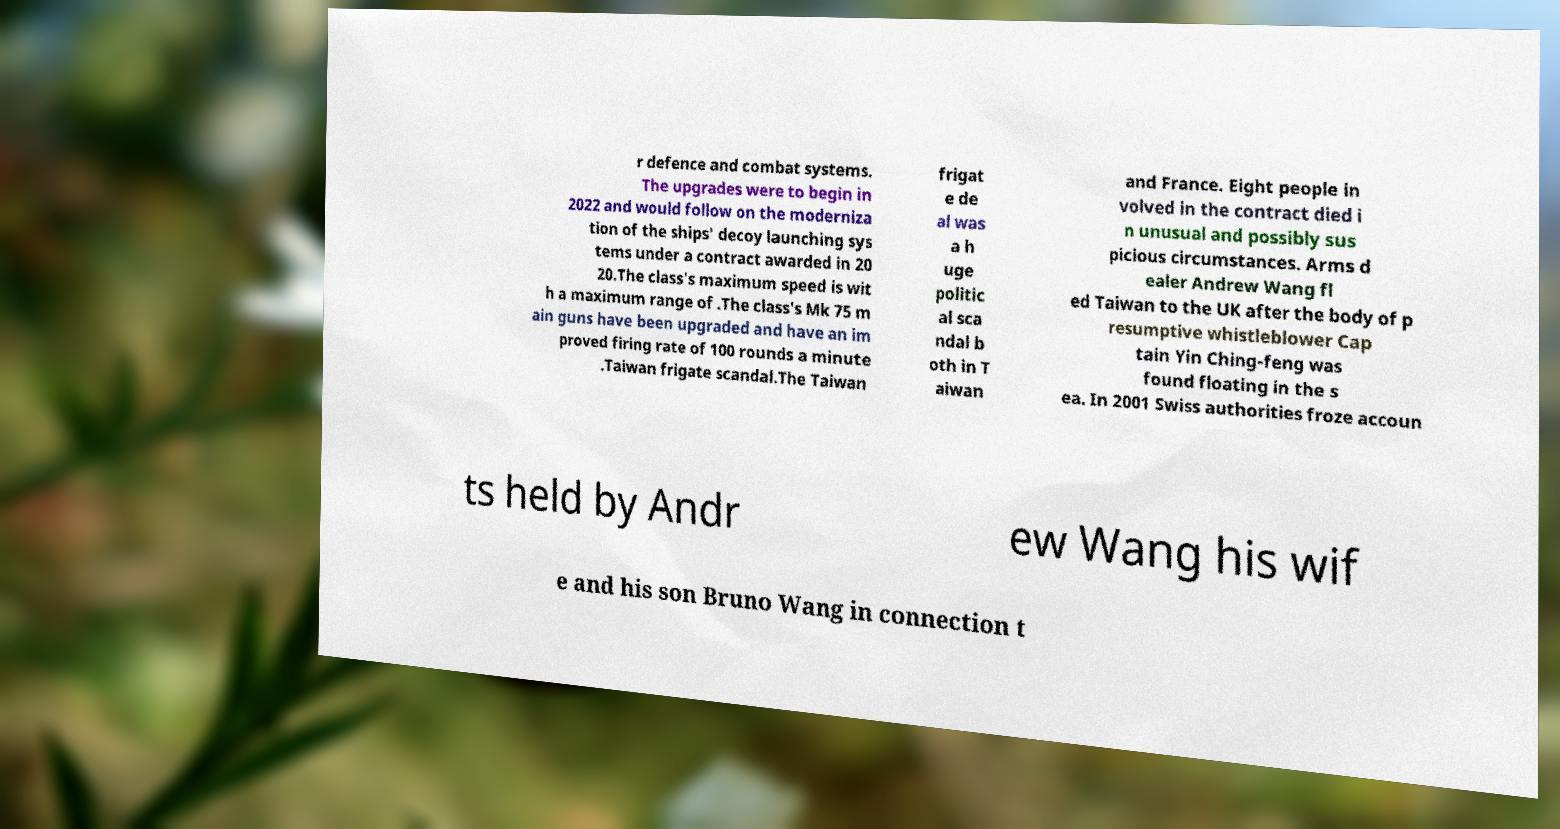Please identify and transcribe the text found in this image. r defence and combat systems. The upgrades were to begin in 2022 and would follow on the moderniza tion of the ships' decoy launching sys tems under a contract awarded in 20 20.The class's maximum speed is wit h a maximum range of .The class's Mk 75 m ain guns have been upgraded and have an im proved firing rate of 100 rounds a minute .Taiwan frigate scandal.The Taiwan frigat e de al was a h uge politic al sca ndal b oth in T aiwan and France. Eight people in volved in the contract died i n unusual and possibly sus picious circumstances. Arms d ealer Andrew Wang fl ed Taiwan to the UK after the body of p resumptive whistleblower Cap tain Yin Ching-feng was found floating in the s ea. In 2001 Swiss authorities froze accoun ts held by Andr ew Wang his wif e and his son Bruno Wang in connection t 